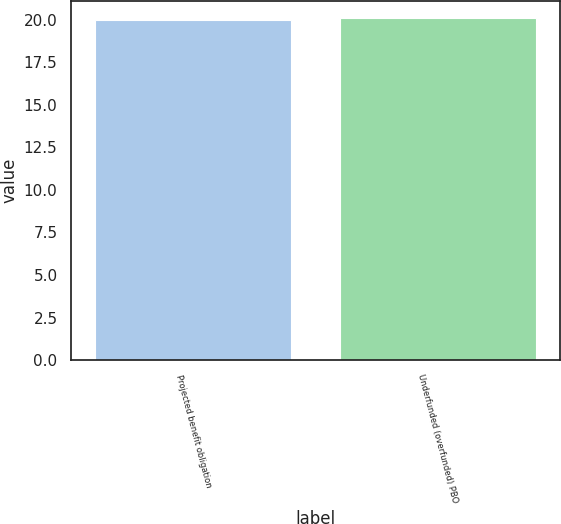Convert chart to OTSL. <chart><loc_0><loc_0><loc_500><loc_500><bar_chart><fcel>Projected benefit obligation<fcel>Underfunded (overfunded) PBO<nl><fcel>20<fcel>20.1<nl></chart> 